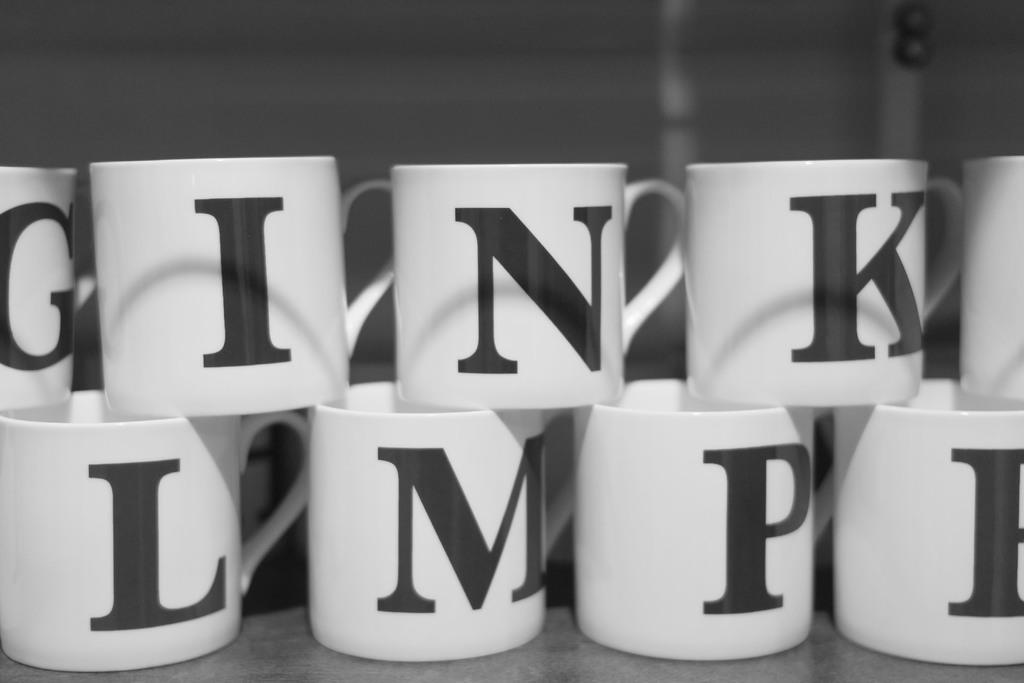<image>
Render a clear and concise summary of the photo. the letter P is on the cup next to other cups 